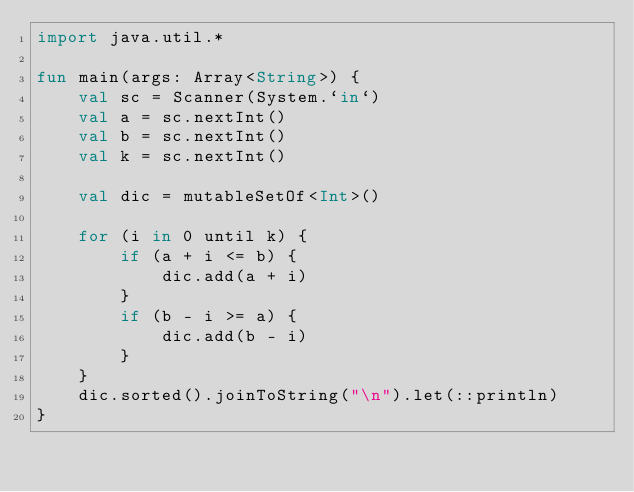<code> <loc_0><loc_0><loc_500><loc_500><_Kotlin_>import java.util.*

fun main(args: Array<String>) {
    val sc = Scanner(System.`in`)
    val a = sc.nextInt()
    val b = sc.nextInt()
    val k = sc.nextInt()

    val dic = mutableSetOf<Int>()

    for (i in 0 until k) {
        if (a + i <= b) {
            dic.add(a + i)
        }
        if (b - i >= a) {
            dic.add(b - i)
        }
    }
    dic.sorted().joinToString("\n").let(::println)
}
</code> 